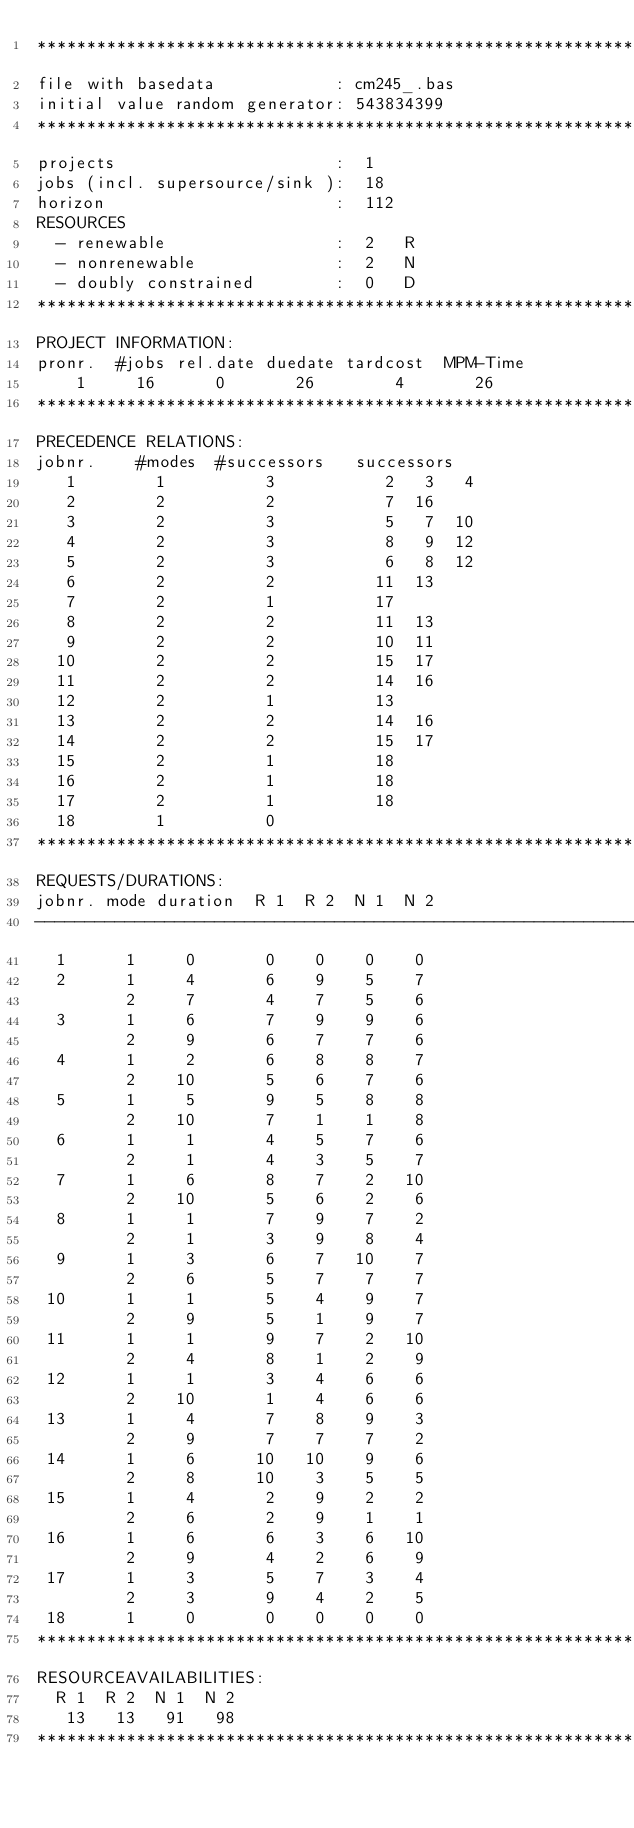Convert code to text. <code><loc_0><loc_0><loc_500><loc_500><_ObjectiveC_>************************************************************************
file with basedata            : cm245_.bas
initial value random generator: 543834399
************************************************************************
projects                      :  1
jobs (incl. supersource/sink ):  18
horizon                       :  112
RESOURCES
  - renewable                 :  2   R
  - nonrenewable              :  2   N
  - doubly constrained        :  0   D
************************************************************************
PROJECT INFORMATION:
pronr.  #jobs rel.date duedate tardcost  MPM-Time
    1     16      0       26        4       26
************************************************************************
PRECEDENCE RELATIONS:
jobnr.    #modes  #successors   successors
   1        1          3           2   3   4
   2        2          2           7  16
   3        2          3           5   7  10
   4        2          3           8   9  12
   5        2          3           6   8  12
   6        2          2          11  13
   7        2          1          17
   8        2          2          11  13
   9        2          2          10  11
  10        2          2          15  17
  11        2          2          14  16
  12        2          1          13
  13        2          2          14  16
  14        2          2          15  17
  15        2          1          18
  16        2          1          18
  17        2          1          18
  18        1          0        
************************************************************************
REQUESTS/DURATIONS:
jobnr. mode duration  R 1  R 2  N 1  N 2
------------------------------------------------------------------------
  1      1     0       0    0    0    0
  2      1     4       6    9    5    7
         2     7       4    7    5    6
  3      1     6       7    9    9    6
         2     9       6    7    7    6
  4      1     2       6    8    8    7
         2    10       5    6    7    6
  5      1     5       9    5    8    8
         2    10       7    1    1    8
  6      1     1       4    5    7    6
         2     1       4    3    5    7
  7      1     6       8    7    2   10
         2    10       5    6    2    6
  8      1     1       7    9    7    2
         2     1       3    9    8    4
  9      1     3       6    7   10    7
         2     6       5    7    7    7
 10      1     1       5    4    9    7
         2     9       5    1    9    7
 11      1     1       9    7    2   10
         2     4       8    1    2    9
 12      1     1       3    4    6    6
         2    10       1    4    6    6
 13      1     4       7    8    9    3
         2     9       7    7    7    2
 14      1     6      10   10    9    6
         2     8      10    3    5    5
 15      1     4       2    9    2    2
         2     6       2    9    1    1
 16      1     6       6    3    6   10
         2     9       4    2    6    9
 17      1     3       5    7    3    4
         2     3       9    4    2    5
 18      1     0       0    0    0    0
************************************************************************
RESOURCEAVAILABILITIES:
  R 1  R 2  N 1  N 2
   13   13   91   98
************************************************************************
</code> 